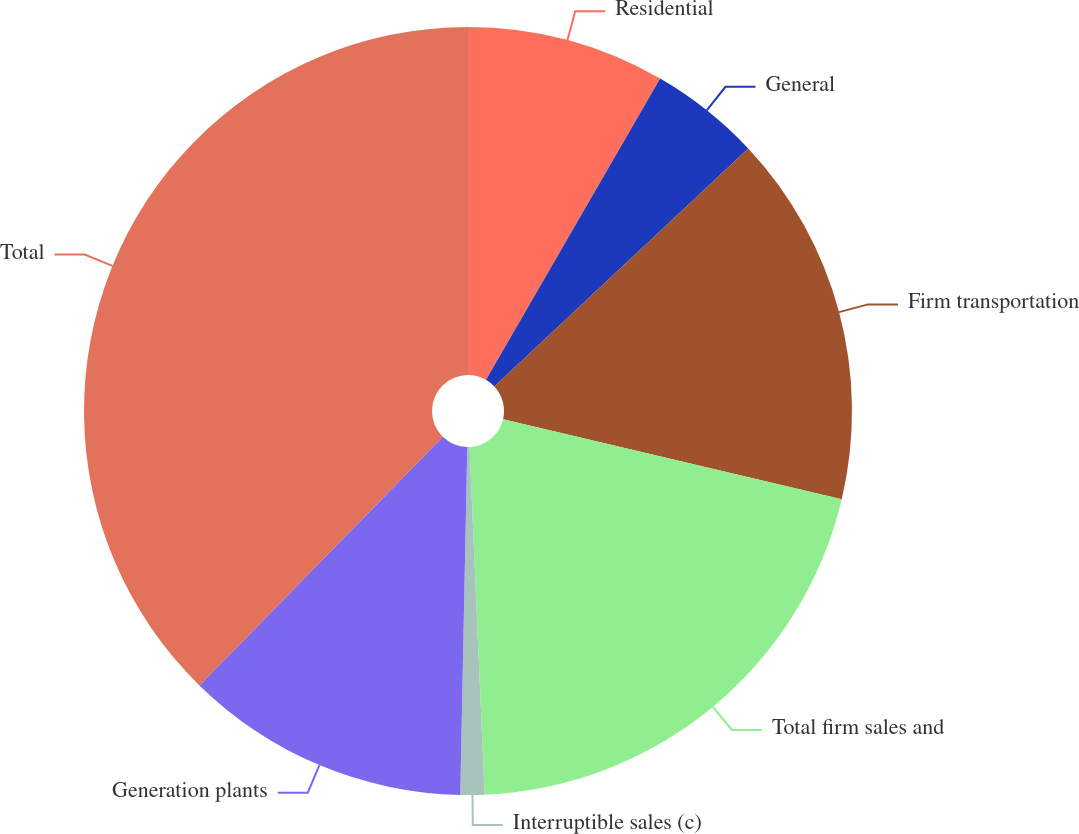<chart> <loc_0><loc_0><loc_500><loc_500><pie_chart><fcel>Residential<fcel>General<fcel>Firm transportation<fcel>Total firm sales and<fcel>Interruptible sales (c)<fcel>Generation plants<fcel>Total<nl><fcel>8.34%<fcel>4.68%<fcel>15.67%<fcel>20.62%<fcel>1.01%<fcel>12.01%<fcel>37.67%<nl></chart> 